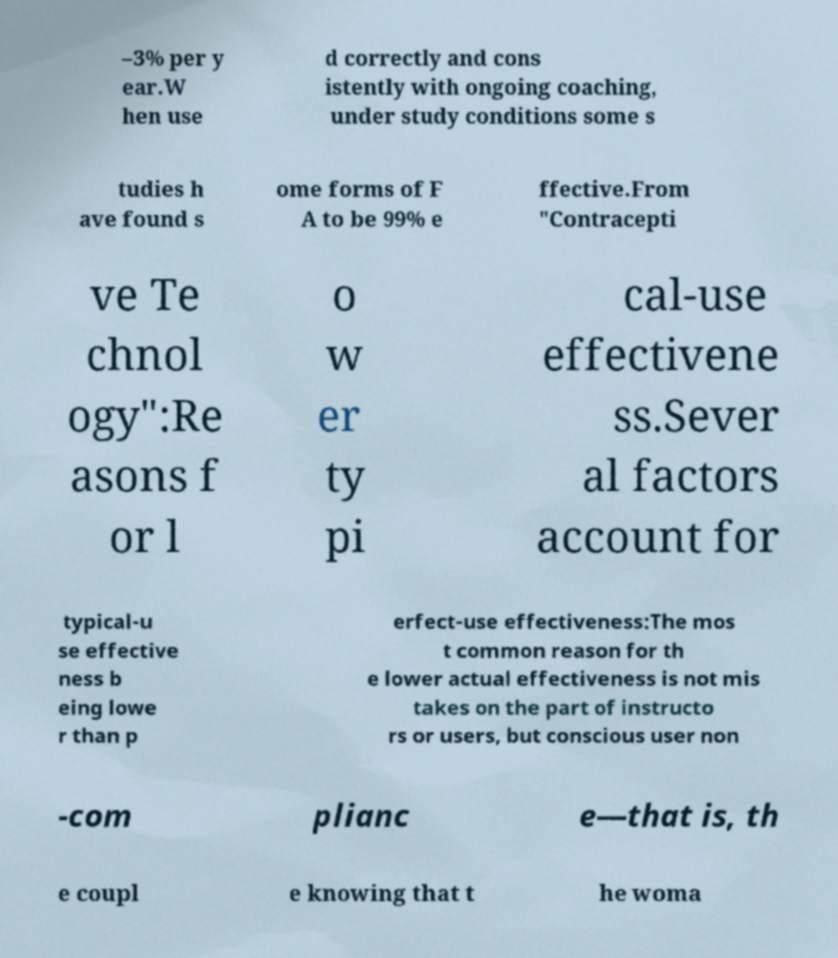Could you extract and type out the text from this image? –3% per y ear.W hen use d correctly and cons istently with ongoing coaching, under study conditions some s tudies h ave found s ome forms of F A to be 99% e ffective.From "Contracepti ve Te chnol ogy":Re asons f or l o w er ty pi cal-use effectivene ss.Sever al factors account for typical-u se effective ness b eing lowe r than p erfect-use effectiveness:The mos t common reason for th e lower actual effectiveness is not mis takes on the part of instructo rs or users, but conscious user non -com plianc e—that is, th e coupl e knowing that t he woma 